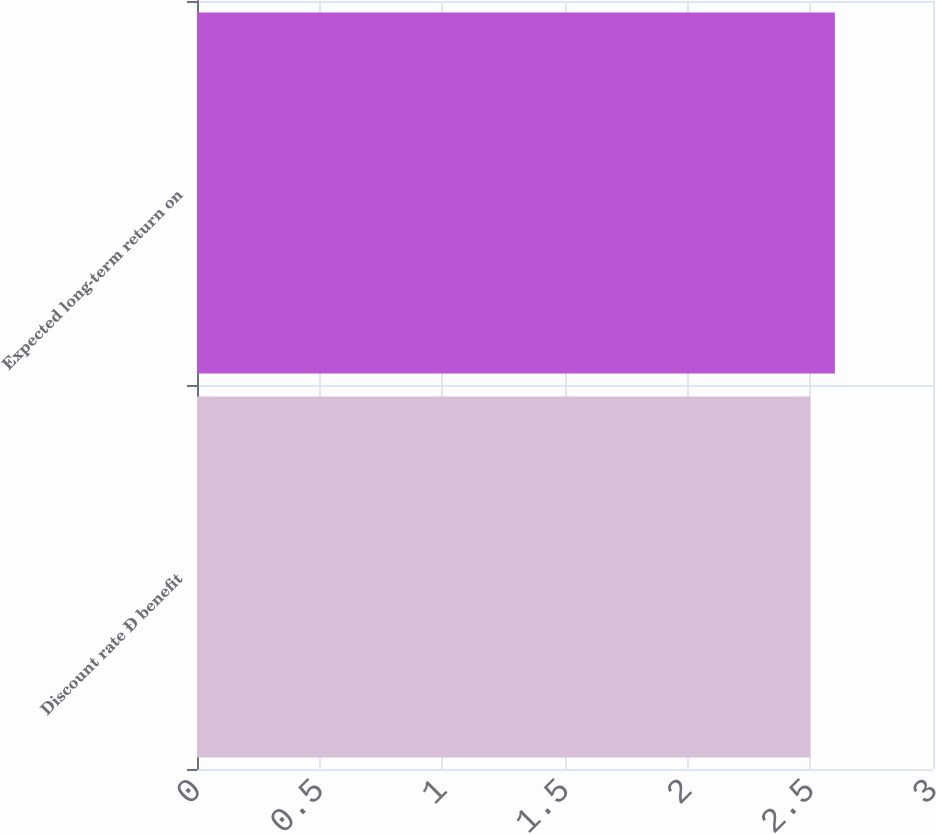Convert chart. <chart><loc_0><loc_0><loc_500><loc_500><bar_chart><fcel>Discount rate Ð benefit<fcel>Expected long-term return on<nl><fcel>2.5<fcel>2.6<nl></chart> 